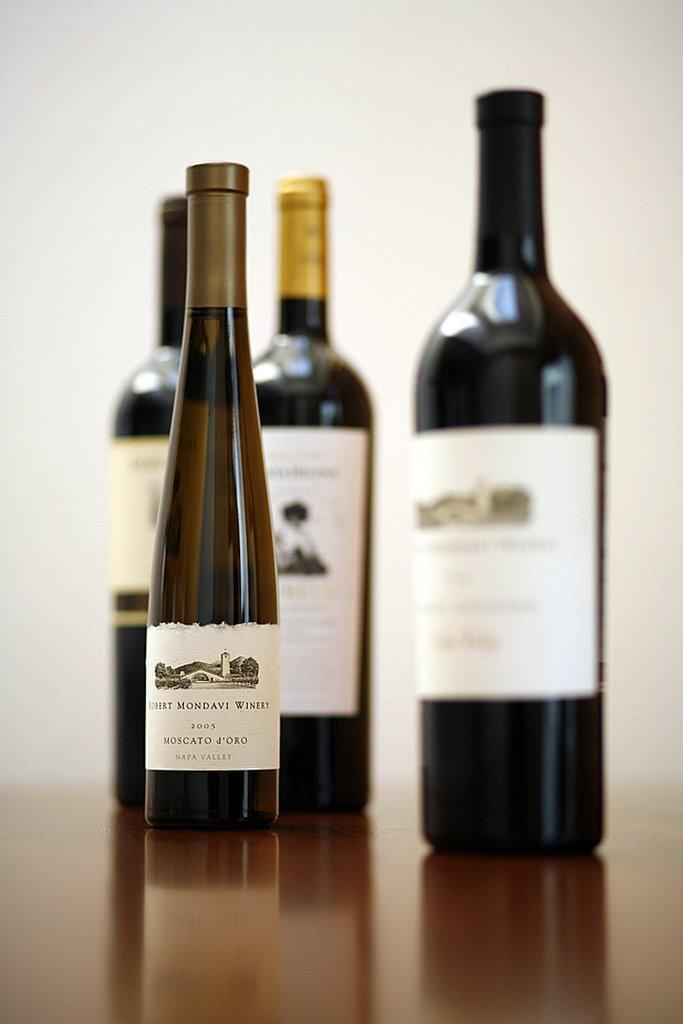<image>
Present a compact description of the photo's key features. A group of four bottles of wine are presented, including a Robert Mondavi Winery 2005 MOSCATO J'ORO with Napa Valley on it. 